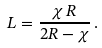<formula> <loc_0><loc_0><loc_500><loc_500>L = \frac { \chi \, R } { 2 R - \chi } \, .</formula> 